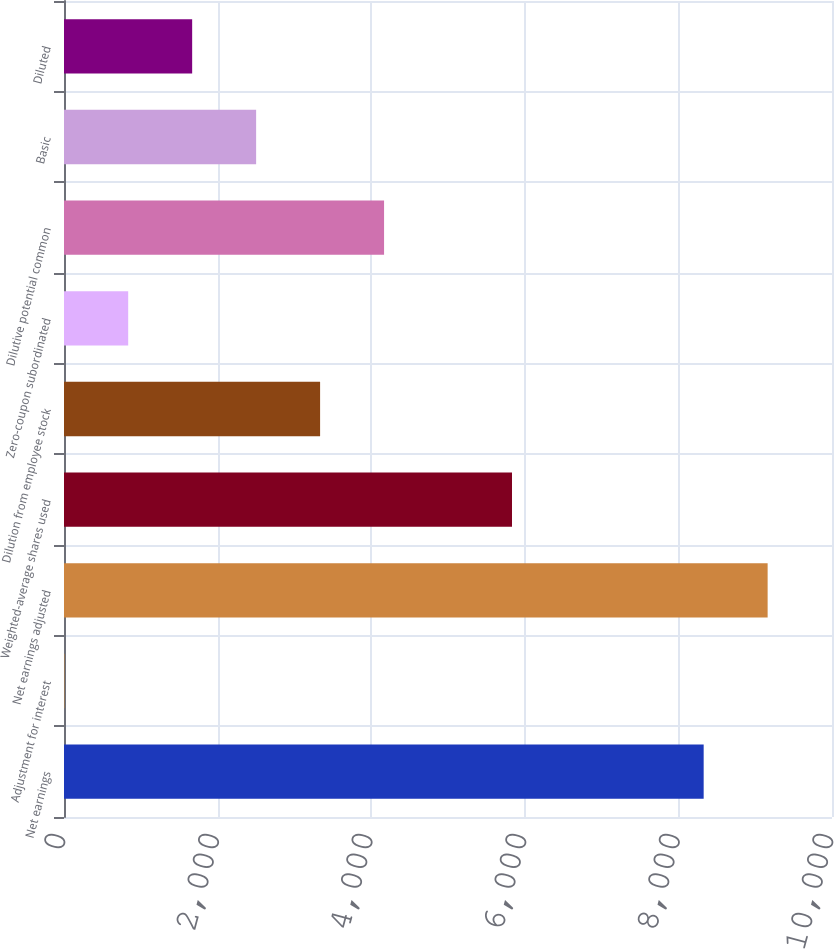<chart> <loc_0><loc_0><loc_500><loc_500><bar_chart><fcel>Net earnings<fcel>Adjustment for interest<fcel>Net earnings adjusted<fcel>Weighted-average shares used<fcel>Dilution from employee stock<fcel>Zero-coupon subordinated<fcel>Dilutive potential common<fcel>Basic<fcel>Diluted<nl><fcel>8329<fcel>3<fcel>9161.9<fcel>5833.3<fcel>3334.6<fcel>835.9<fcel>4167.5<fcel>2501.7<fcel>1668.8<nl></chart> 